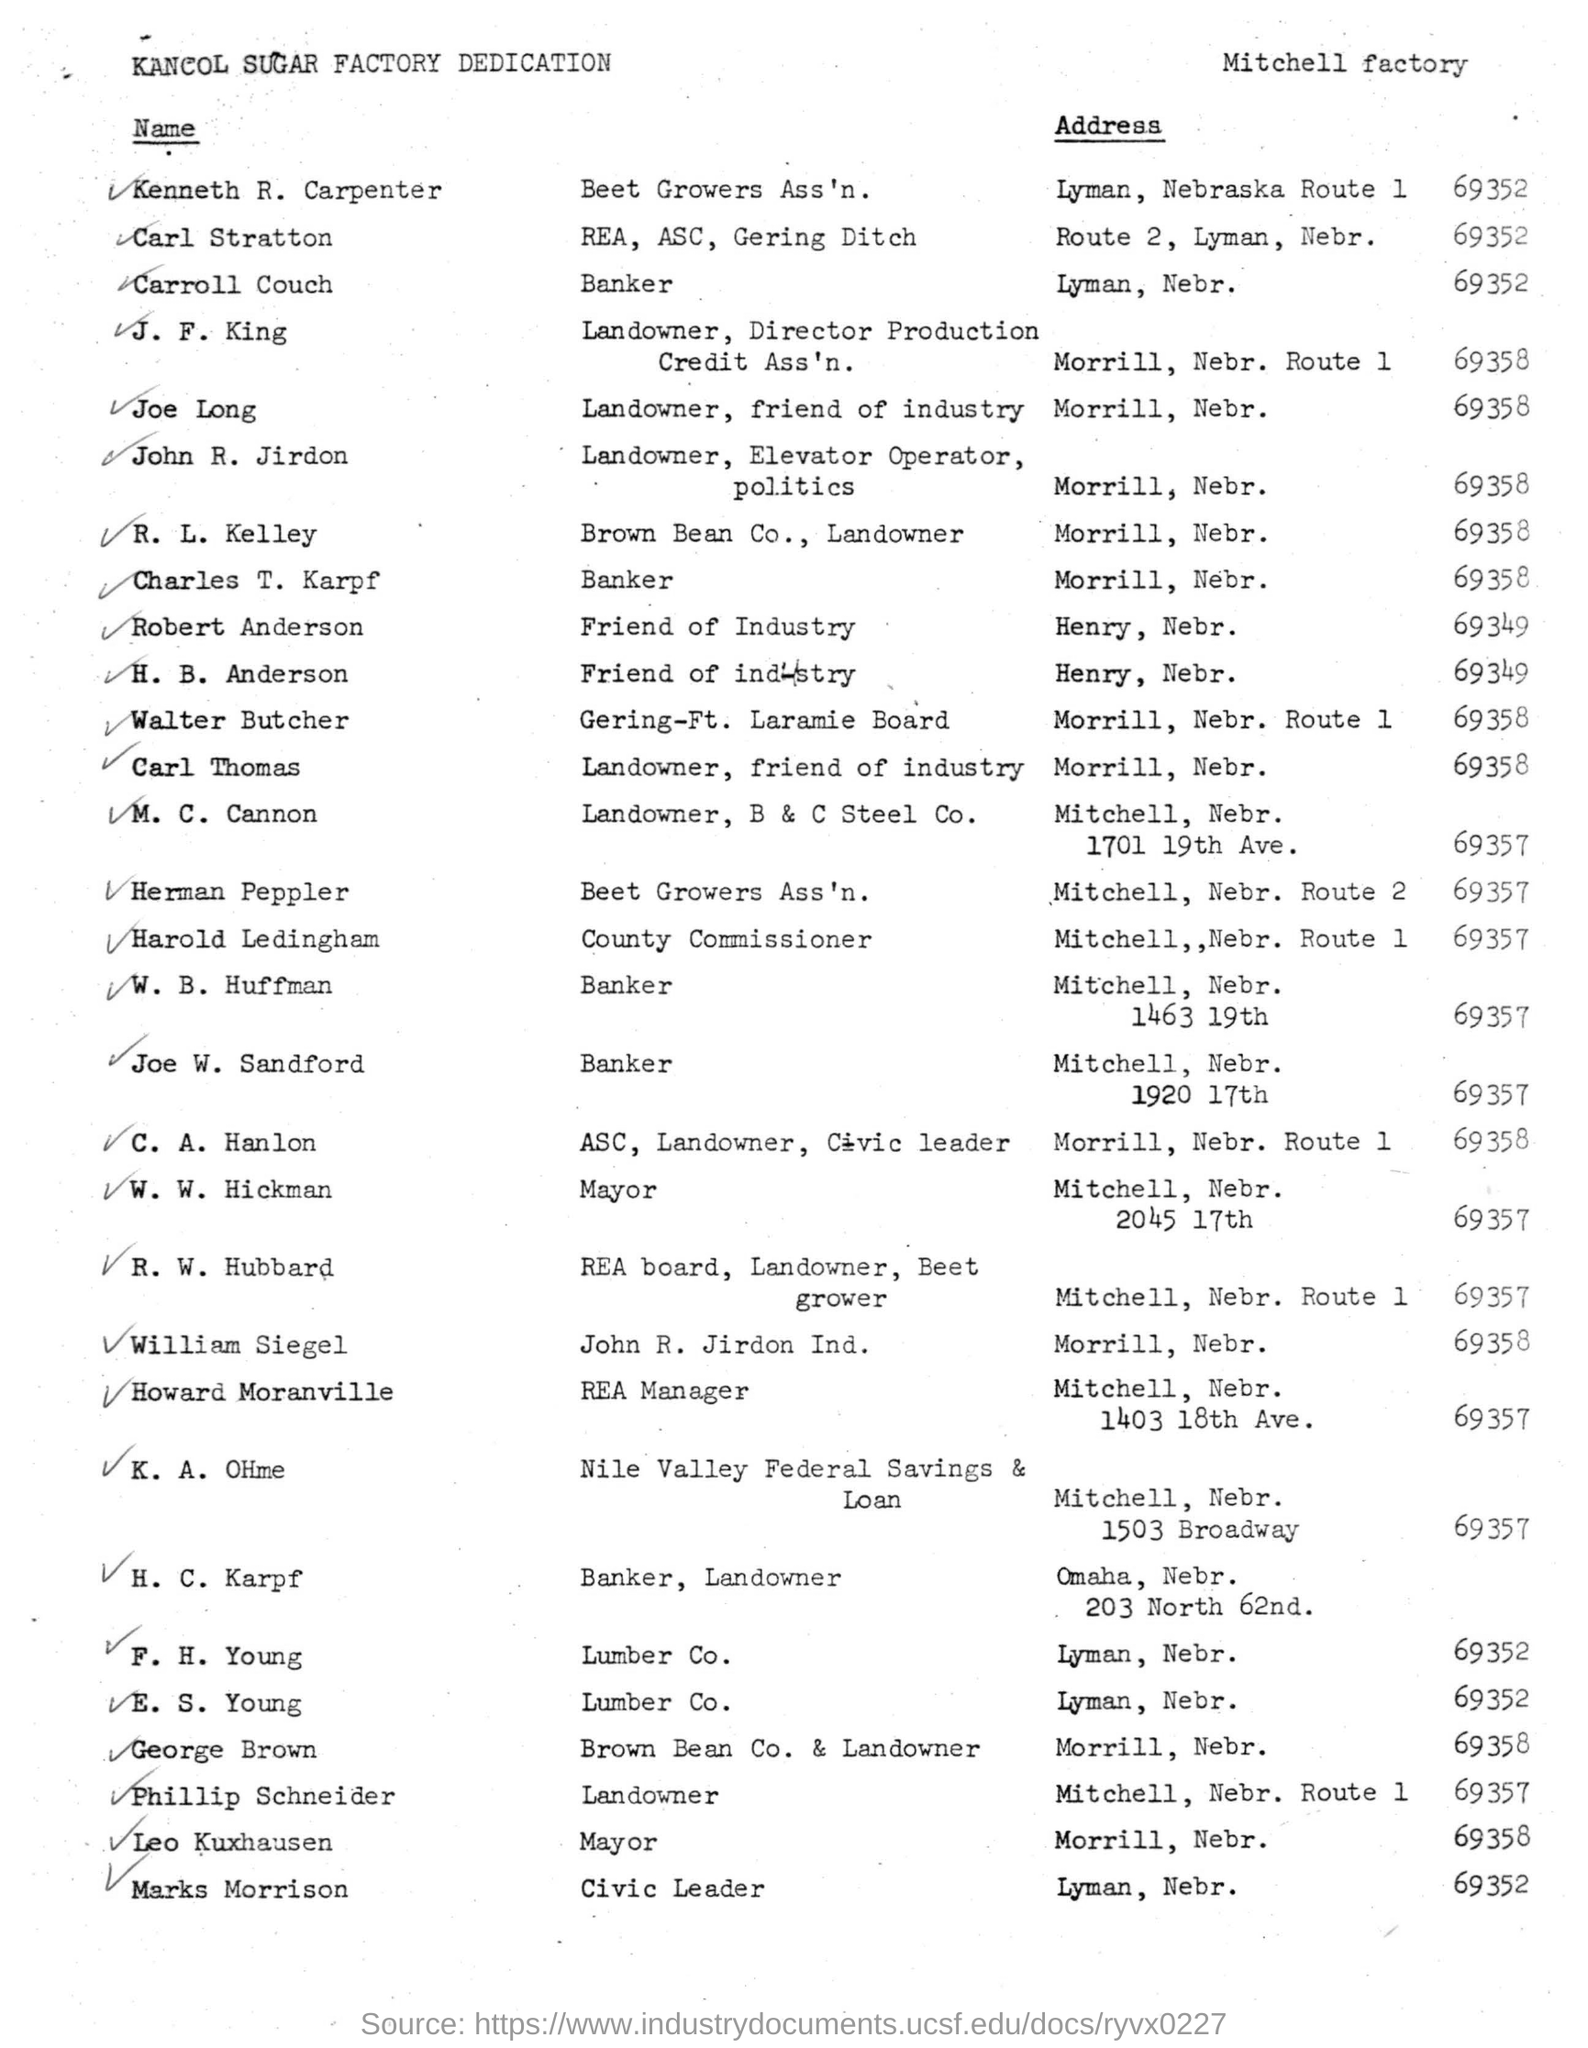What is the route number of walter butcher?
Give a very brief answer. 1. 